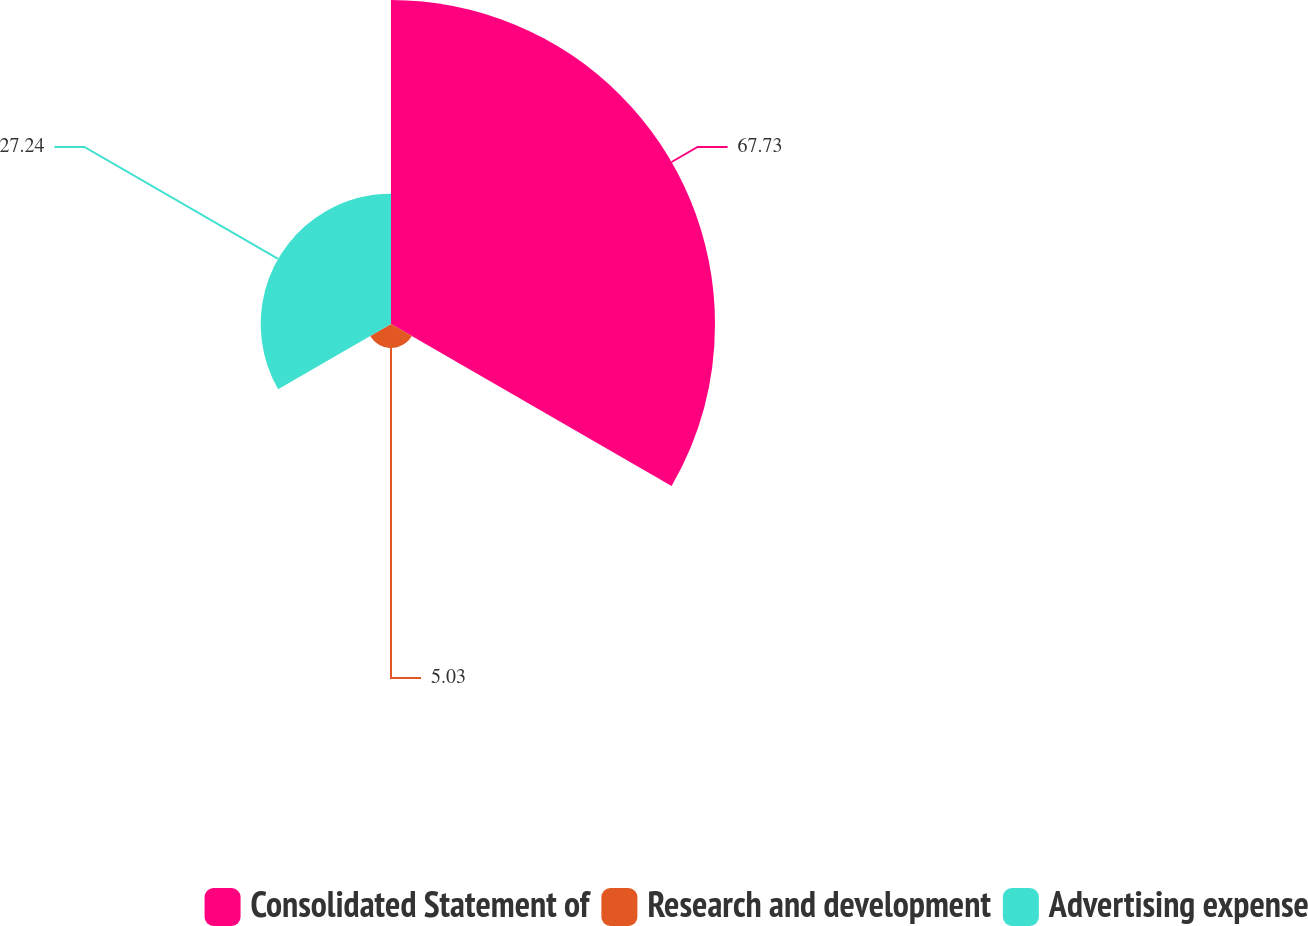Convert chart to OTSL. <chart><loc_0><loc_0><loc_500><loc_500><pie_chart><fcel>Consolidated Statement of<fcel>Research and development<fcel>Advertising expense<nl><fcel>67.72%<fcel>5.03%<fcel>27.24%<nl></chart> 